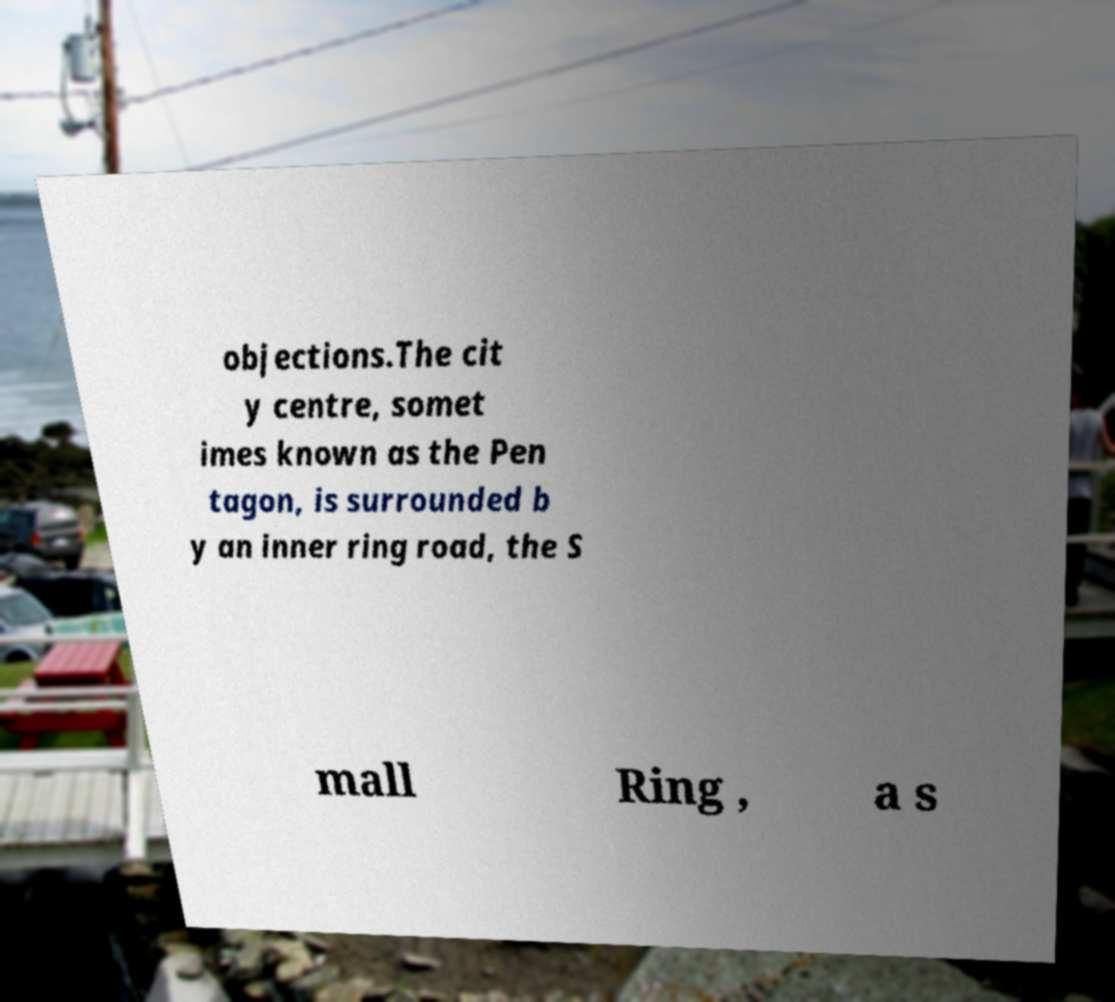For documentation purposes, I need the text within this image transcribed. Could you provide that? objections.The cit y centre, somet imes known as the Pen tagon, is surrounded b y an inner ring road, the S mall Ring , a s 